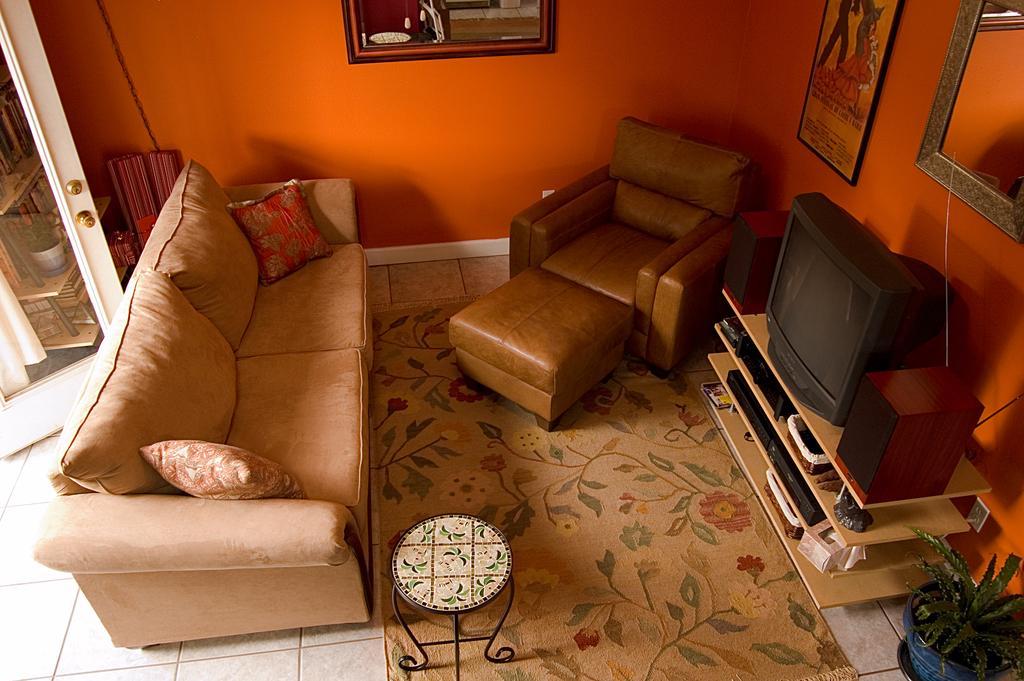Can you describe this image briefly? This image is taken inside a room. In the left side of the image there is a door, a sofa with pillows on it. In the right side of the image there is a plant with a pot, a table which has few things on it and a monitor. At the bottom of the image there is a floor with mat and stool. At the background there is a wall with few paintings and frames on it. 